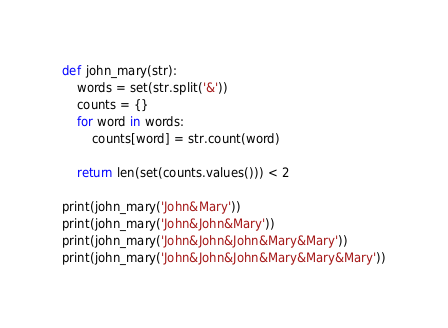Convert code to text. <code><loc_0><loc_0><loc_500><loc_500><_Python_>def john_mary(str):
    words = set(str.split('&'))
    counts = {}
    for word in words:
        counts[word] = str.count(word)

    return len(set(counts.values())) < 2

print(john_mary('John&Mary'))
print(john_mary('John&John&Mary'))
print(john_mary('John&John&John&Mary&Mary'))
print(john_mary('John&John&John&Mary&Mary&Mary'))
</code> 